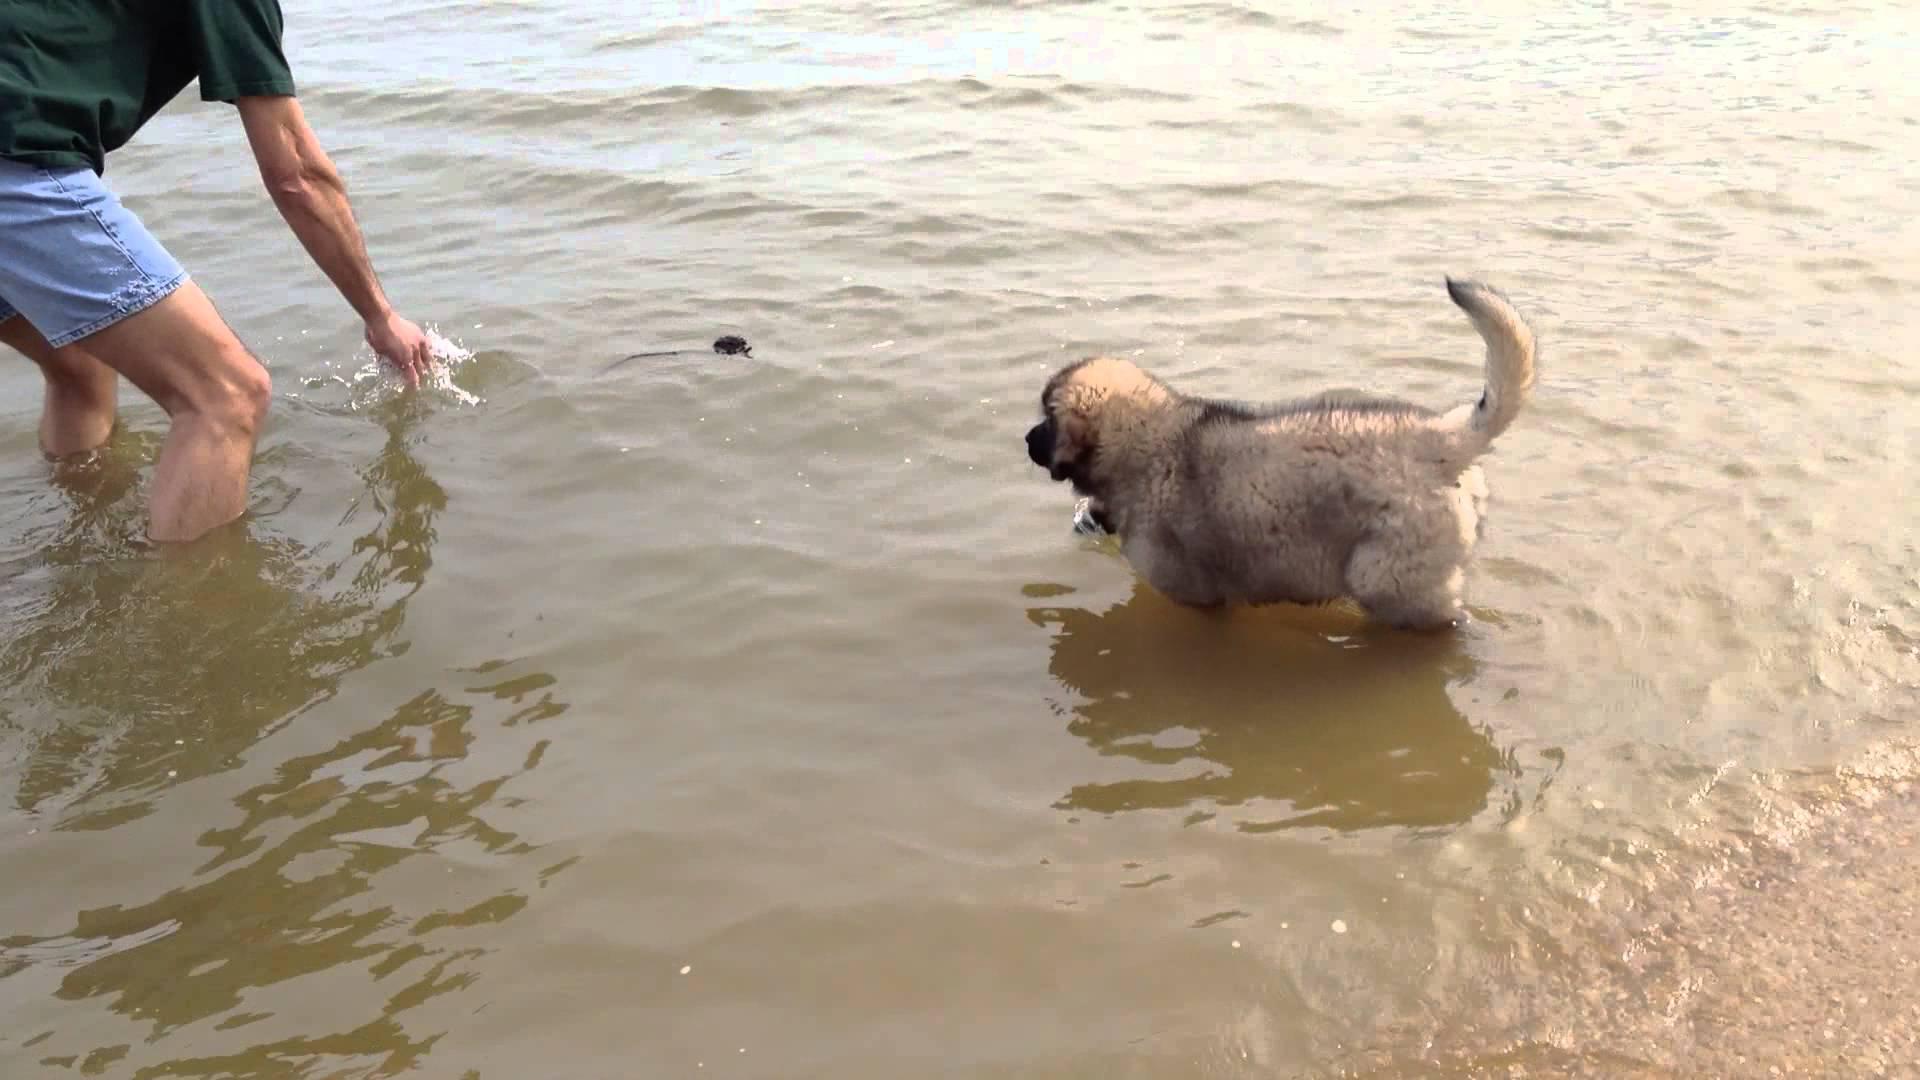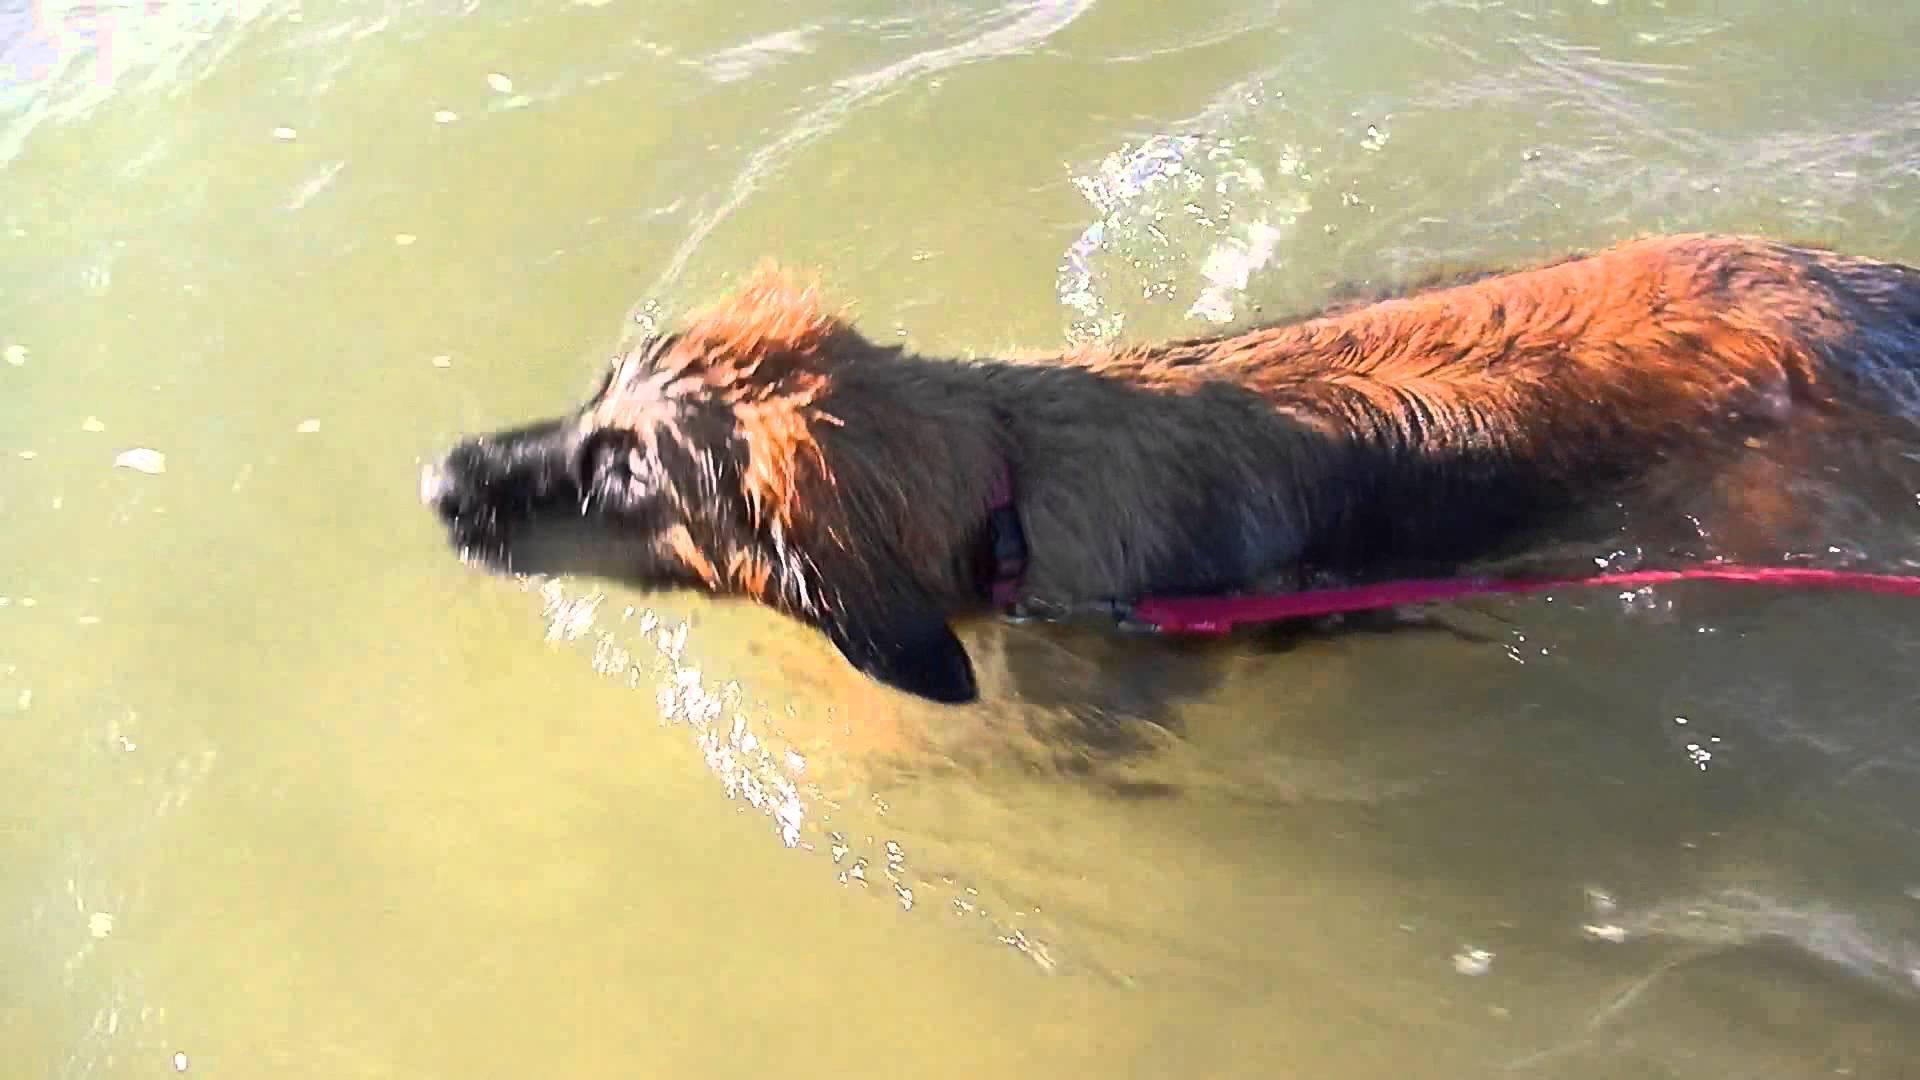The first image is the image on the left, the second image is the image on the right. Examine the images to the left and right. Is the description "The dog in the right image is in water facing towards the left." accurate? Answer yes or no. Yes. The first image is the image on the left, the second image is the image on the right. Analyze the images presented: Is the assertion "Two dog are in a natural body of water." valid? Answer yes or no. Yes. 